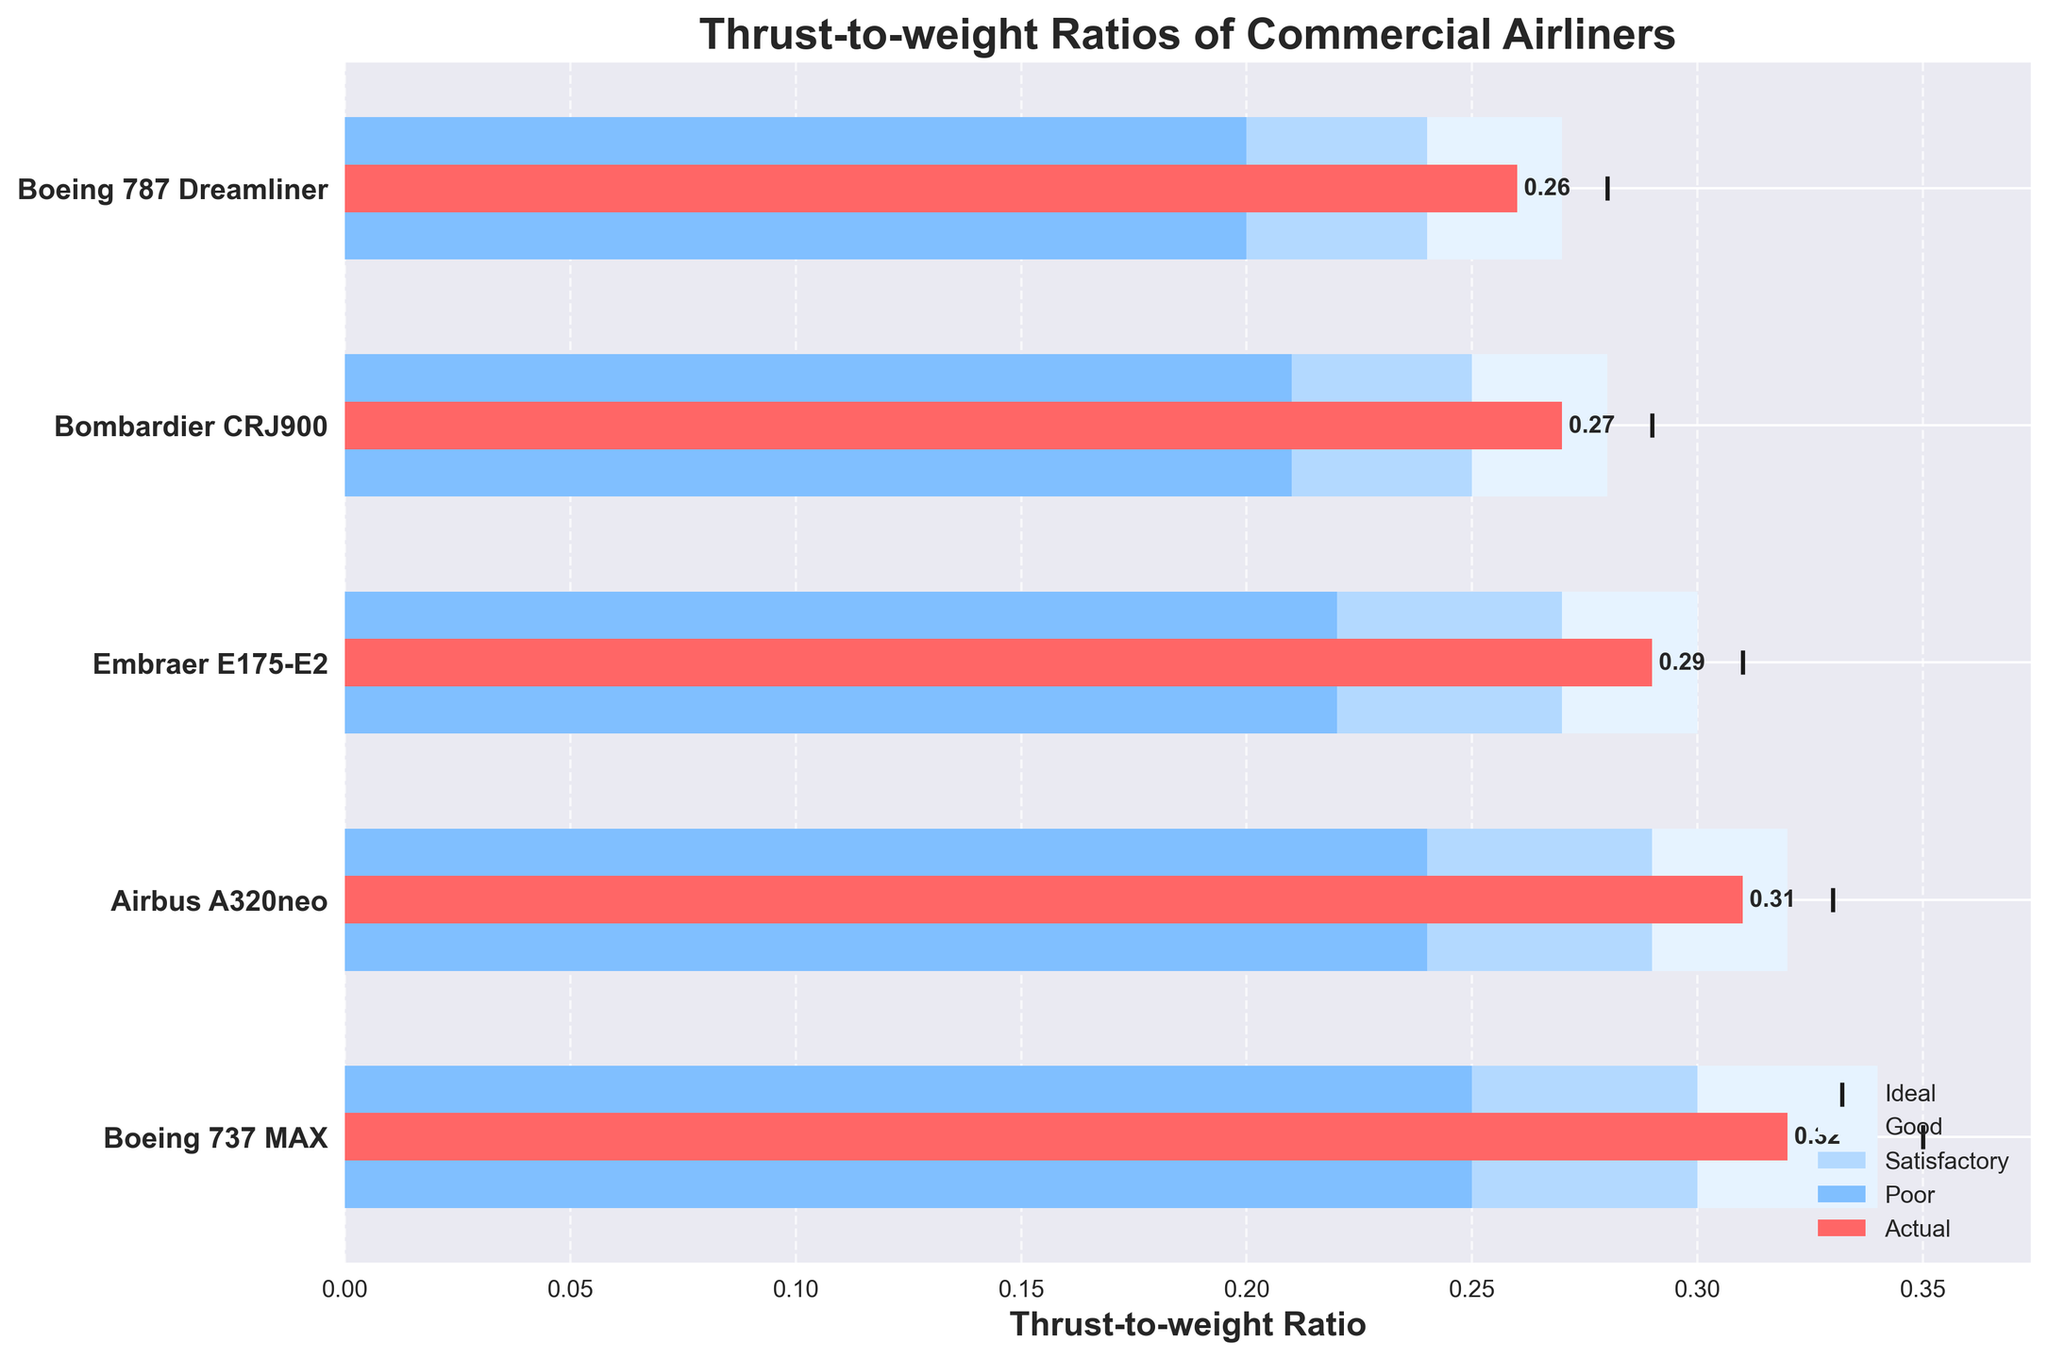What is the title of the figure? The title of the figure is typically displayed at the top and provides a summary of what the chart is about.
Answer: Thrust-to-weight Ratios of Commercial Airliners Which airliner has the highest actual thrust-to-weight ratio? By examining the length of the red bars representing "Actual", we can determine which is the longest.
Answer: Boeing 737 MAX How does the actual thrust-to-weight ratio of the Airbus A320neo compare to its ideal value? Identify the red bar for Airbus A320neo and compare it to the vertical black line (ideal) to see if it's lower, higher, or equal.
Answer: Lower What is the thrust-to-weight ratio for the Bombardier CRJ900 in the "Good" category? The length of the light blue horizontal bar for Bombardier CRJ900 signifies the upper limit of the "Good" category.
Answer: 0.28 Which airliner has the smallest difference between its actual and ideal thrust-to-weight ratios? Calculate the difference between actual and ideal values for each airliner and determine the smallest difference.
Answer: Airbus A320neo Are there any airliners with an actual thrust-to-weight ratio in the "Poor" category? Check if any of the red bars fall within the dark blue range labeled "Poor."
Answer: No How many airliners have an actual thrust-to-weight ratio in the "Satisfactory" category? Count the red bars that fall within the range of the medium blue area labeled "Satisfactory."
Answer: Three What is the span of the "Good" category for the Boeing 787 Dreamliner? Subtract the lower limit of the "Good" category from the upper limit for the Boeing 787 Dreamliner.
Answer: 0.07 (0.27 - 0.20) What would be the impact on rankings if the actual thrust-to-weight ratio of the Boeing 787 Dreamliner increased to 0.30? If Boeing 787 Dreamliner's actual ratio increased to 0.30, it would also need to be checked if any change in relative ordering occurs in the chart.
Answer: Its ranking would remain unchanged; it would still be the lowest among listed airliners Which category (Poor, Satisfactory, or Good) does the Boeing 737 MAX fall into, based on its actual thrust-to-weight ratio? Identify the specific region where the red bar for Boeing 737 MAX falls into among Poor, Satisfactory, and Good.
Answer: Good 